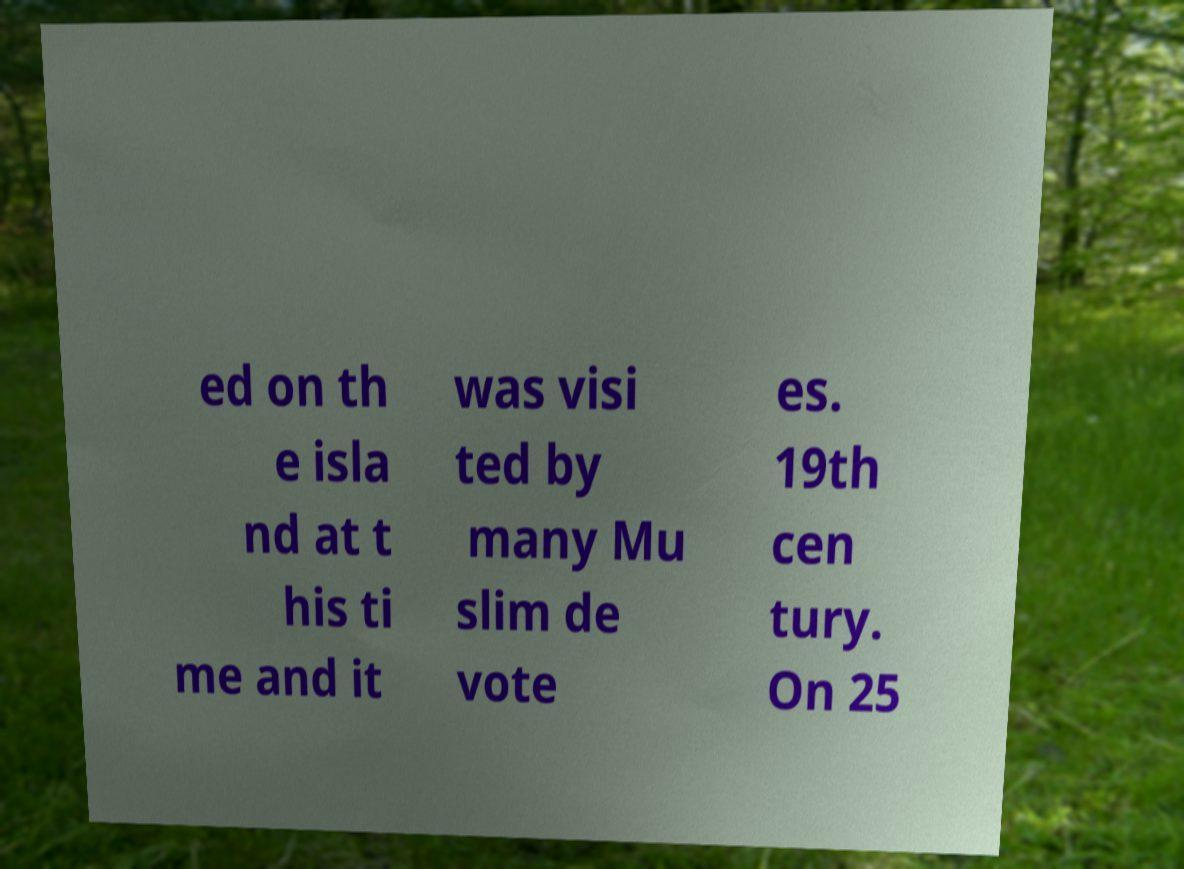For documentation purposes, I need the text within this image transcribed. Could you provide that? ed on th e isla nd at t his ti me and it was visi ted by many Mu slim de vote es. 19th cen tury. On 25 